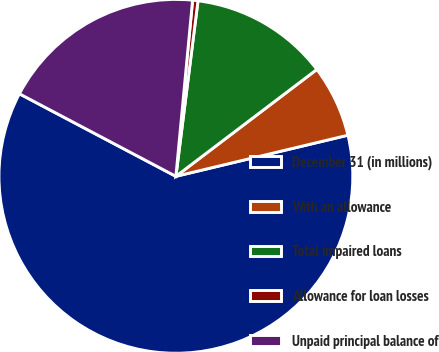Convert chart. <chart><loc_0><loc_0><loc_500><loc_500><pie_chart><fcel>December 31 (in millions)<fcel>With an allowance<fcel>Total impaired loans<fcel>Allowance for loan losses<fcel>Unpaid principal balance of<nl><fcel>61.46%<fcel>6.59%<fcel>12.68%<fcel>0.49%<fcel>18.78%<nl></chart> 